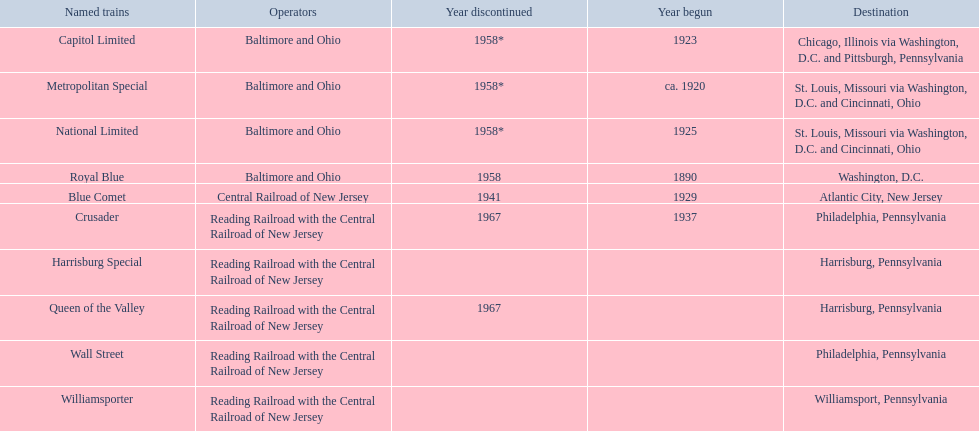Which of the trains are operated by reading railroad with the central railroad of new jersey? Crusader, Harrisburg Special, Queen of the Valley, Wall Street, Williamsporter. Of these trains, which of them had a destination of philadelphia, pennsylvania? Crusader, Wall Street. Out of these two trains, which one is discontinued? Crusader. 